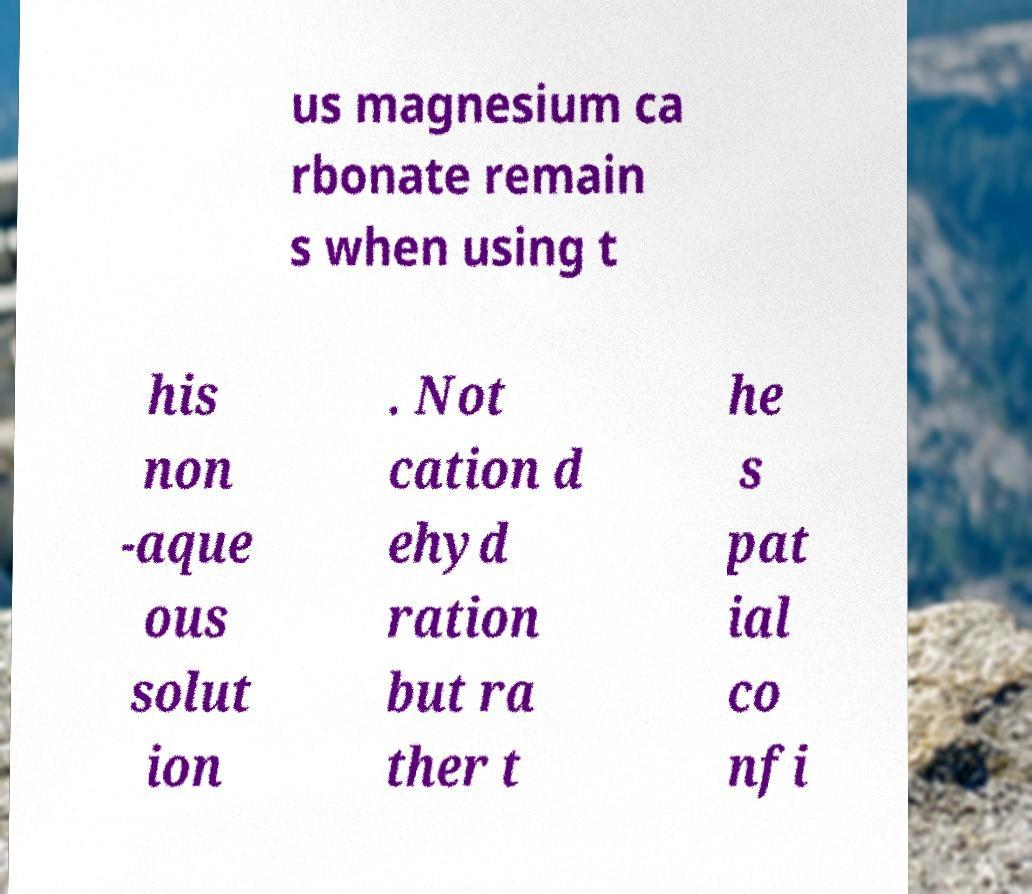Can you accurately transcribe the text from the provided image for me? us magnesium ca rbonate remain s when using t his non -aque ous solut ion . Not cation d ehyd ration but ra ther t he s pat ial co nfi 